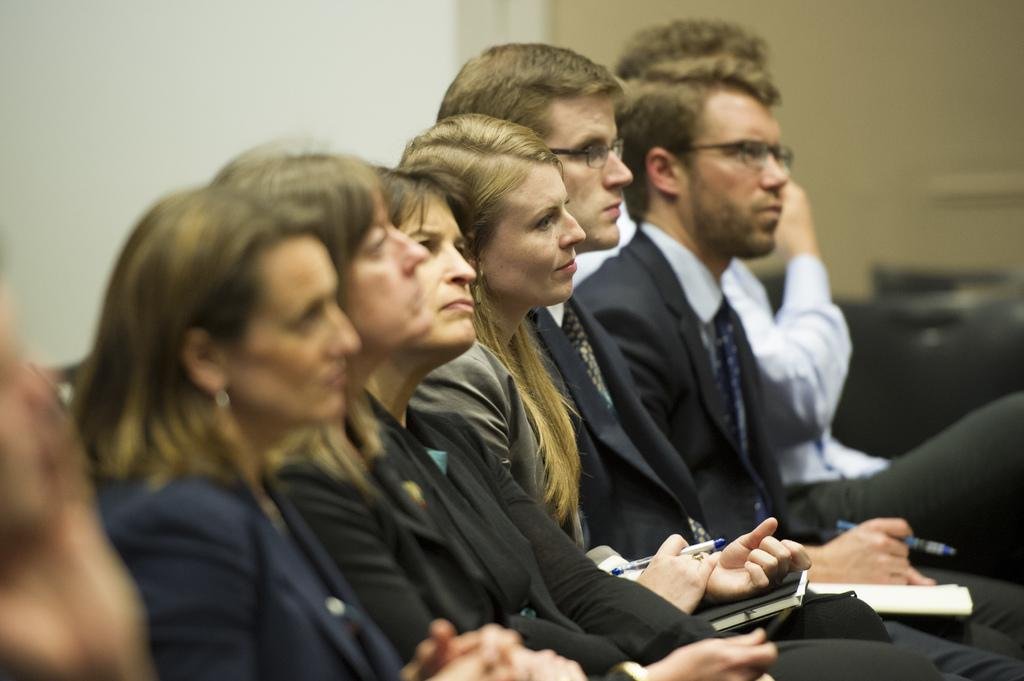What are the people in the image doing? The people in the image are sitting on chairs. What can be seen behind the people in the image? There is a wall visible in the image. How many centimeters of wool can be seen on the chairs in the image? There is no wool visible on the chairs in the image. What letters are written on the wall in the image? There is no information about letters on the wall in the image. 